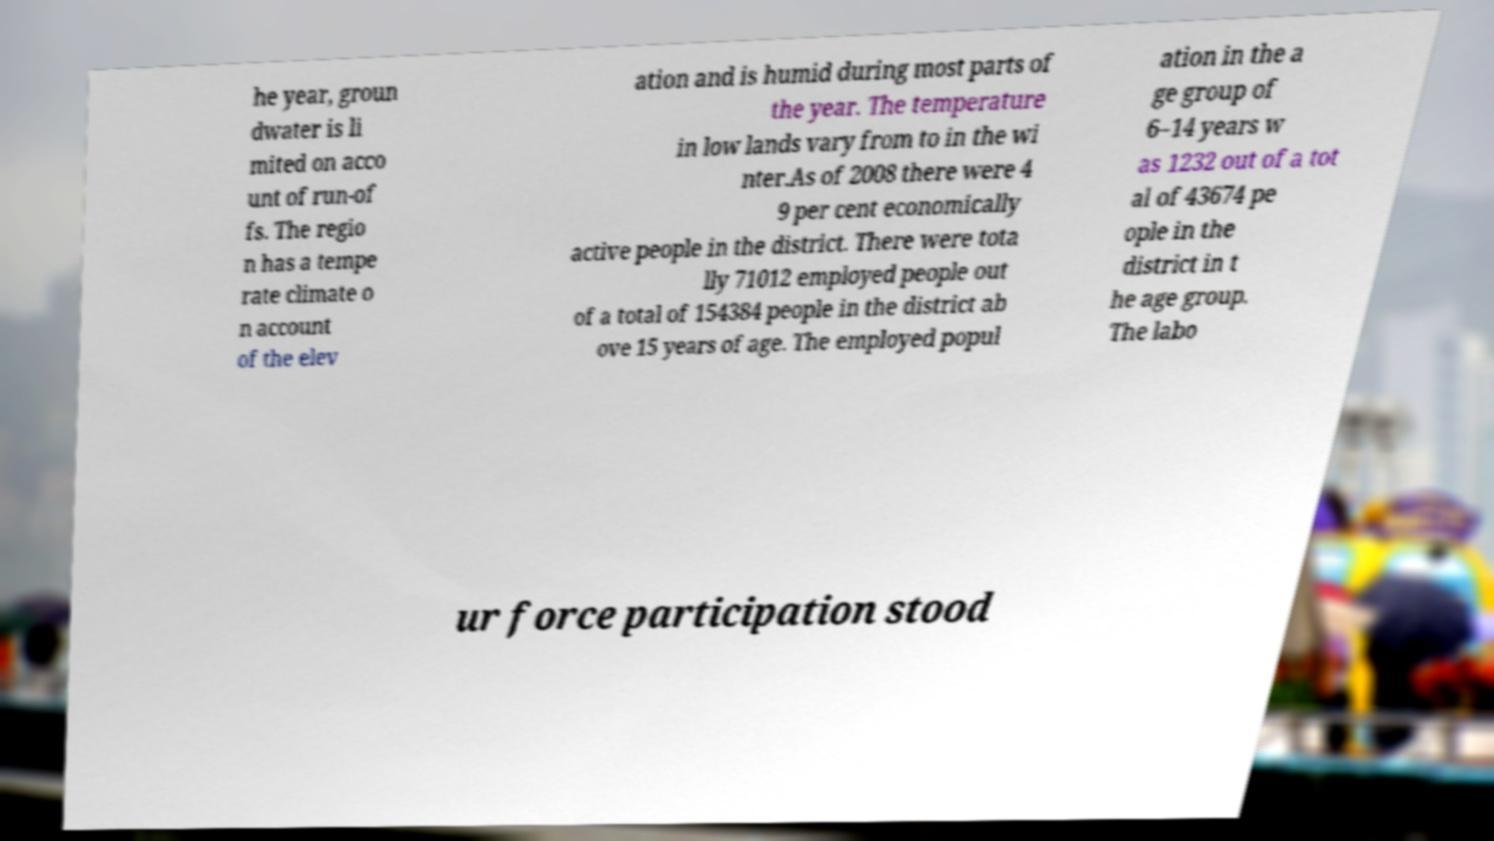Could you assist in decoding the text presented in this image and type it out clearly? he year, groun dwater is li mited on acco unt of run-of fs. The regio n has a tempe rate climate o n account of the elev ation and is humid during most parts of the year. The temperature in low lands vary from to in the wi nter.As of 2008 there were 4 9 per cent economically active people in the district. There were tota lly 71012 employed people out of a total of 154384 people in the district ab ove 15 years of age. The employed popul ation in the a ge group of 6–14 years w as 1232 out of a tot al of 43674 pe ople in the district in t he age group. The labo ur force participation stood 